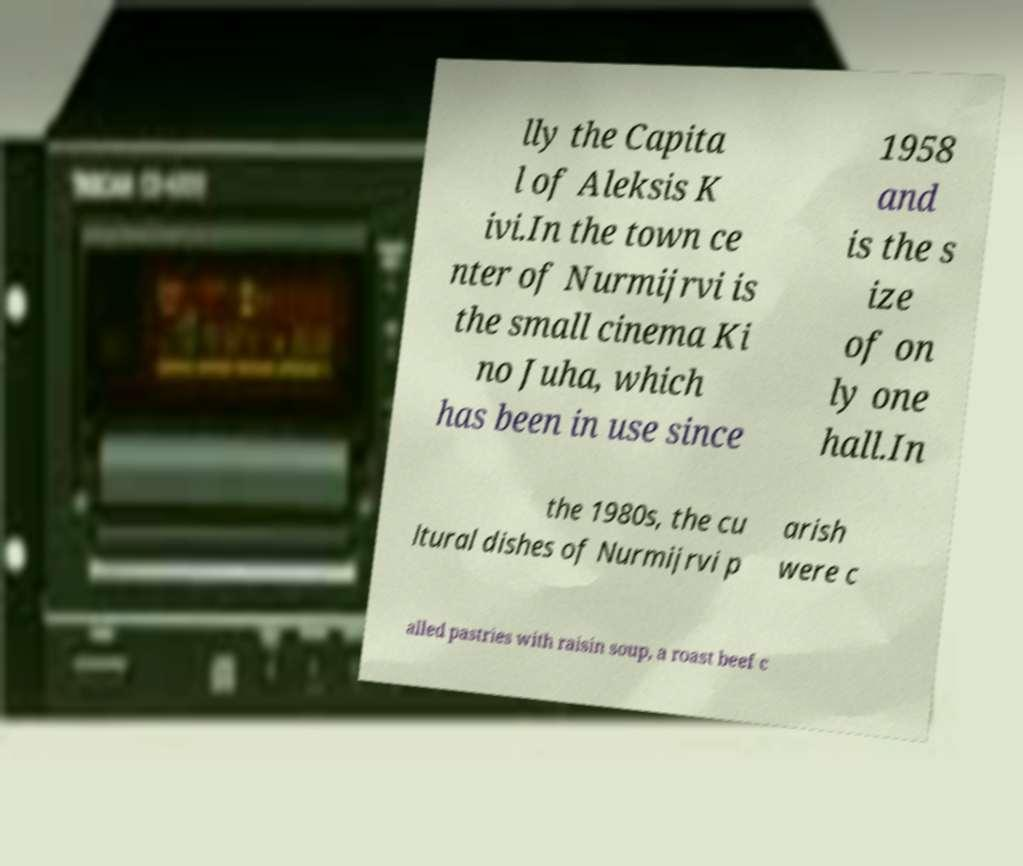There's text embedded in this image that I need extracted. Can you transcribe it verbatim? lly the Capita l of Aleksis K ivi.In the town ce nter of Nurmijrvi is the small cinema Ki no Juha, which has been in use since 1958 and is the s ize of on ly one hall.In the 1980s, the cu ltural dishes of Nurmijrvi p arish were c alled pastries with raisin soup, a roast beef c 